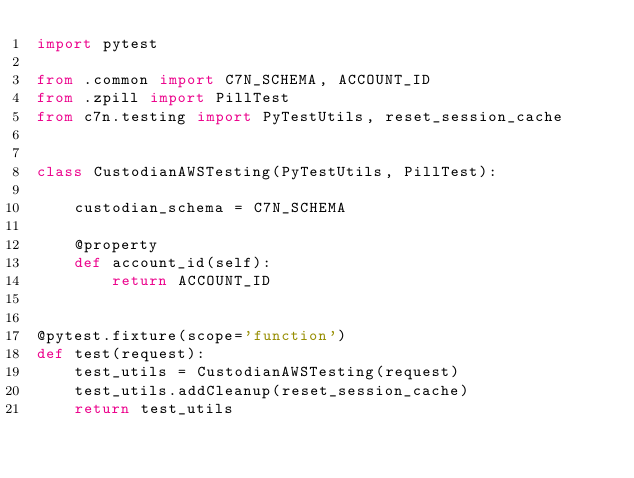<code> <loc_0><loc_0><loc_500><loc_500><_Python_>import pytest

from .common import C7N_SCHEMA, ACCOUNT_ID
from .zpill import PillTest
from c7n.testing import PyTestUtils, reset_session_cache


class CustodianAWSTesting(PyTestUtils, PillTest):

    custodian_schema = C7N_SCHEMA

    @property
    def account_id(self):
        return ACCOUNT_ID


@pytest.fixture(scope='function')
def test(request):
    test_utils = CustodianAWSTesting(request)
    test_utils.addCleanup(reset_session_cache)
    return test_utils
</code> 